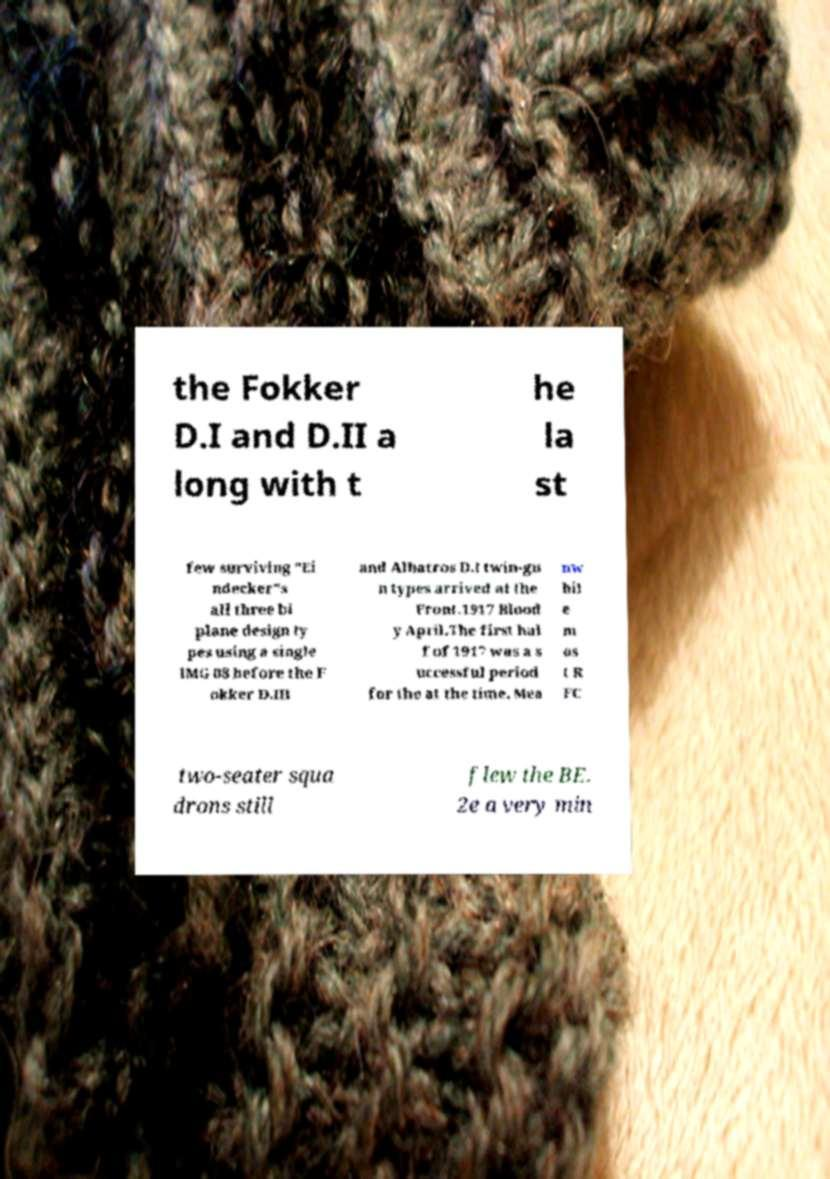I need the written content from this picture converted into text. Can you do that? the Fokker D.I and D.II a long with t he la st few surviving "Ei ndecker"s all three bi plane design ty pes using a single lMG 08 before the F okker D.III and Albatros D.I twin-gu n types arrived at the Front.1917 Blood y April.The first hal f of 1917 was a s uccessful period for the at the time. Mea nw hil e m os t R FC two-seater squa drons still flew the BE. 2e a very min 